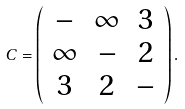<formula> <loc_0><loc_0><loc_500><loc_500>C = \left ( \begin{array} { c c c } - & \infty & 3 \\ \infty & - & 2 \\ 3 & 2 & - \end{array} \right ) .</formula> 